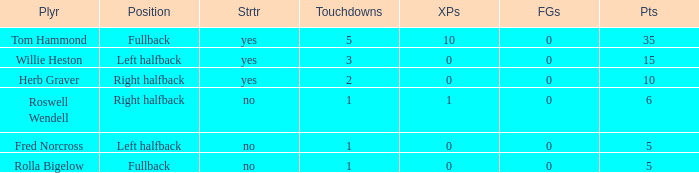What is the lowest number of touchdowns for left halfback WIllie Heston who has more than 15 points? None. 